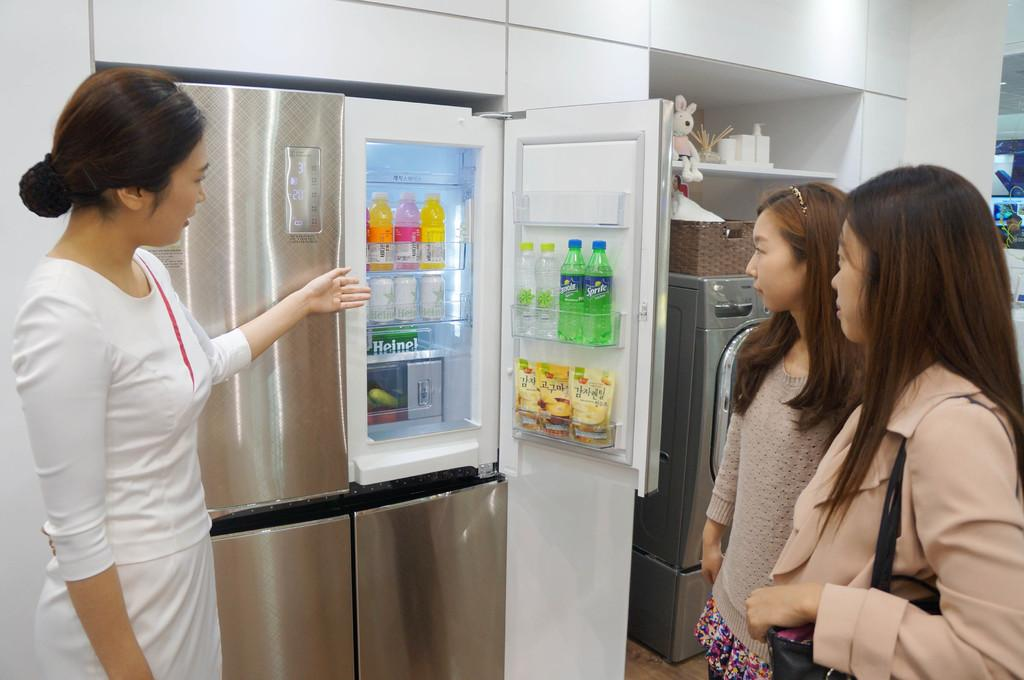<image>
Provide a brief description of the given image. Women presenting a friedge to two women with some sprite bottles inside. 